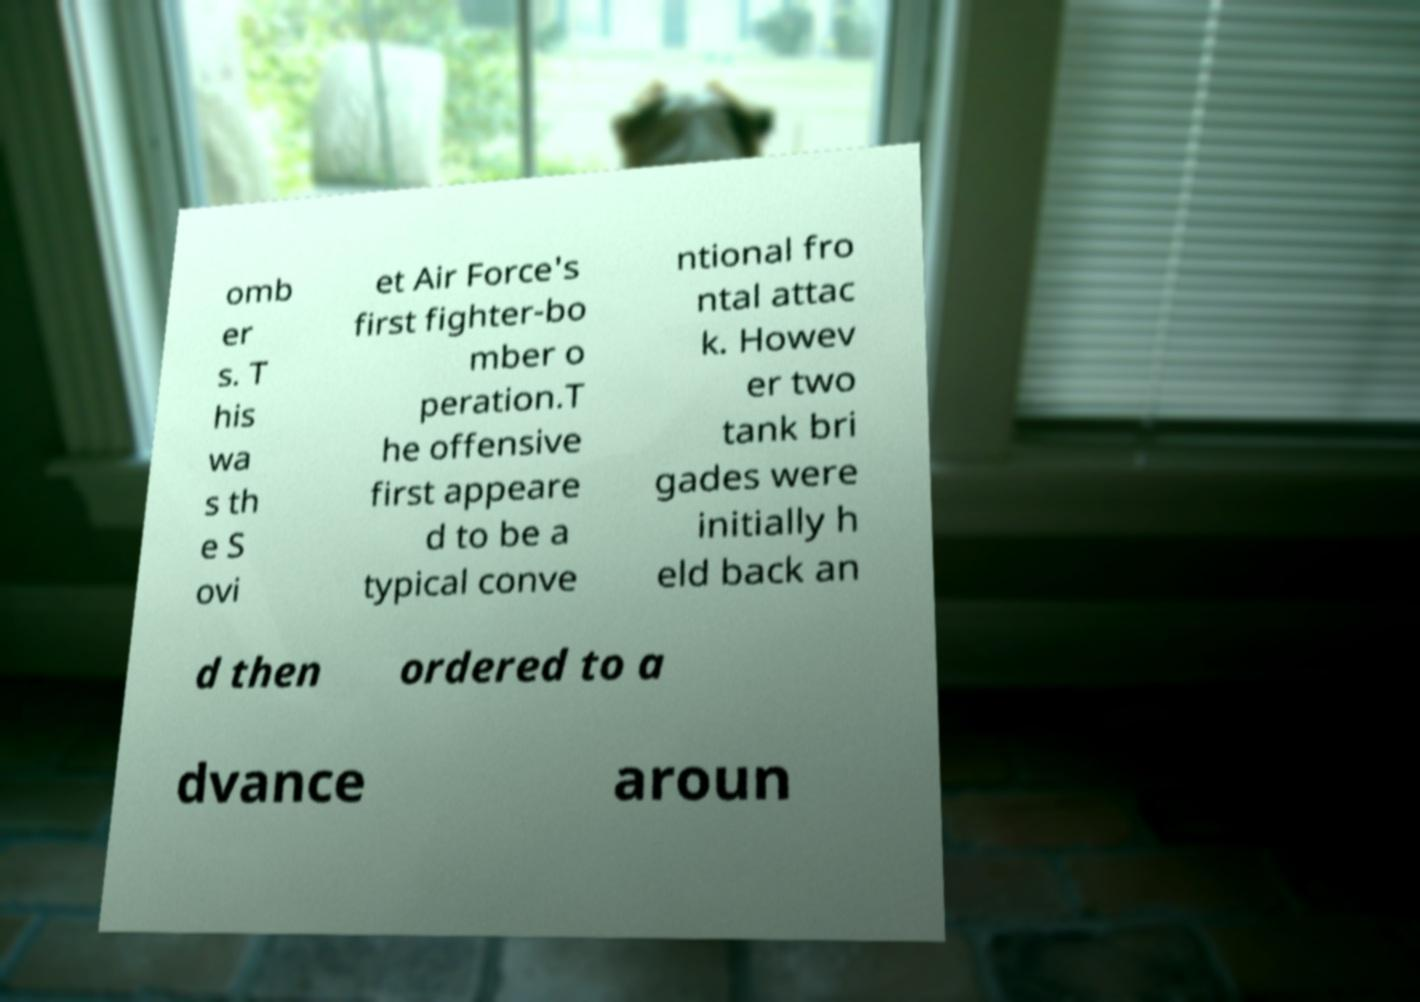Can you read and provide the text displayed in the image?This photo seems to have some interesting text. Can you extract and type it out for me? omb er s. T his wa s th e S ovi et Air Force's first fighter-bo mber o peration.T he offensive first appeare d to be a typical conve ntional fro ntal attac k. Howev er two tank bri gades were initially h eld back an d then ordered to a dvance aroun 